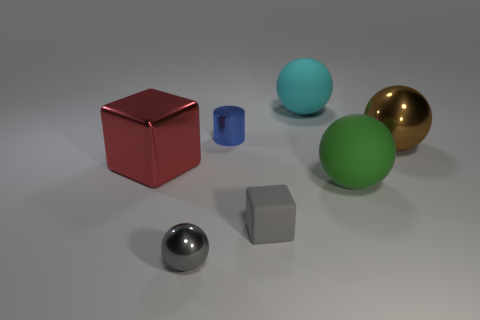Add 1 small gray matte objects. How many objects exist? 8 Subtract all spheres. How many objects are left? 3 Add 6 large things. How many large things are left? 10 Add 4 big blue metallic spheres. How many big blue metallic spheres exist? 4 Subtract 0 brown cylinders. How many objects are left? 7 Subtract all large purple matte spheres. Subtract all red cubes. How many objects are left? 6 